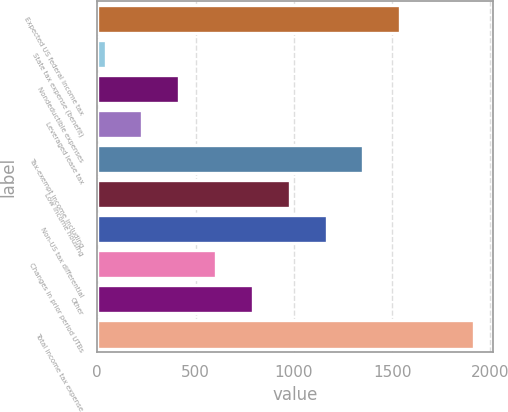Convert chart. <chart><loc_0><loc_0><loc_500><loc_500><bar_chart><fcel>Expected US federal income tax<fcel>State tax expense (benefit)<fcel>Nondeductible expenses<fcel>Leveraged lease tax<fcel>Tax-exempt income including<fcel>Low income housing<fcel>Non-US tax differential<fcel>Changes in prior period UTBs<fcel>Other<fcel>Total income tax expense<nl><fcel>1541.2<fcel>42<fcel>416.8<fcel>229.4<fcel>1353.8<fcel>979<fcel>1166.4<fcel>604.2<fcel>791.6<fcel>1916<nl></chart> 